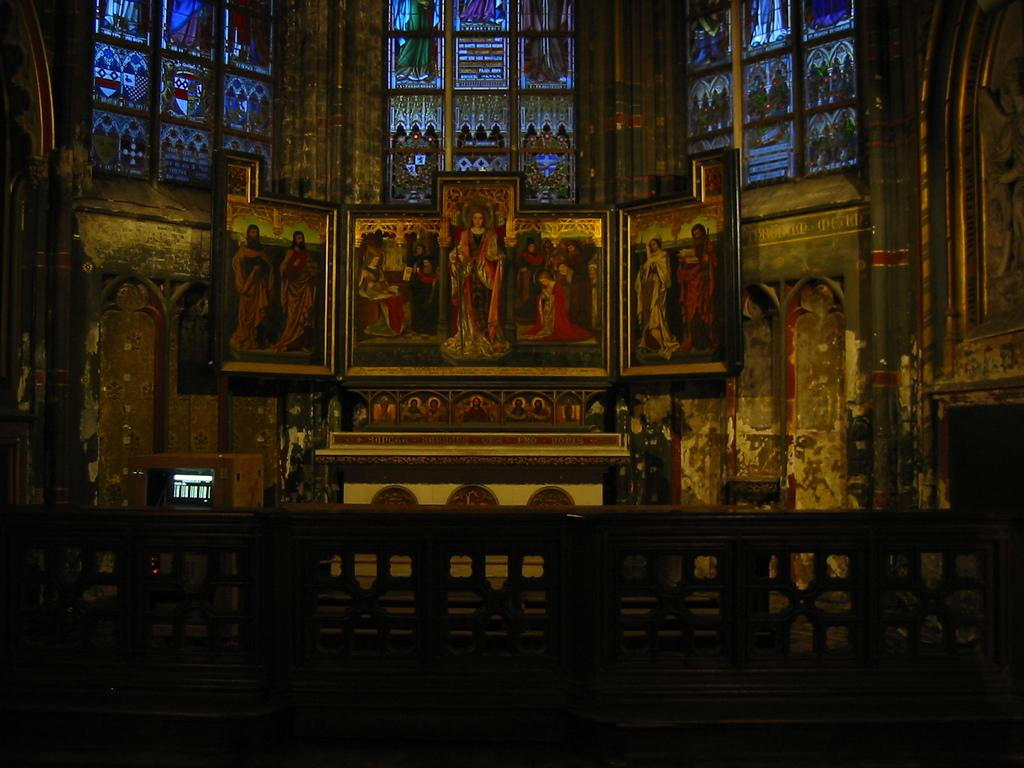What type of location is depicted in the image? The image is an inside view of a holy church. What can be seen on the glasses in the image? There are paintings on the glasses. How would you describe the lighting in the image? The bottom portion of the image is dark. Can you identify any objects in the image? There is an object on the left side of the image. How many frogs are sitting on the trains in the image? There are no frogs or trains present in the image; it is an inside view of a holy church. 